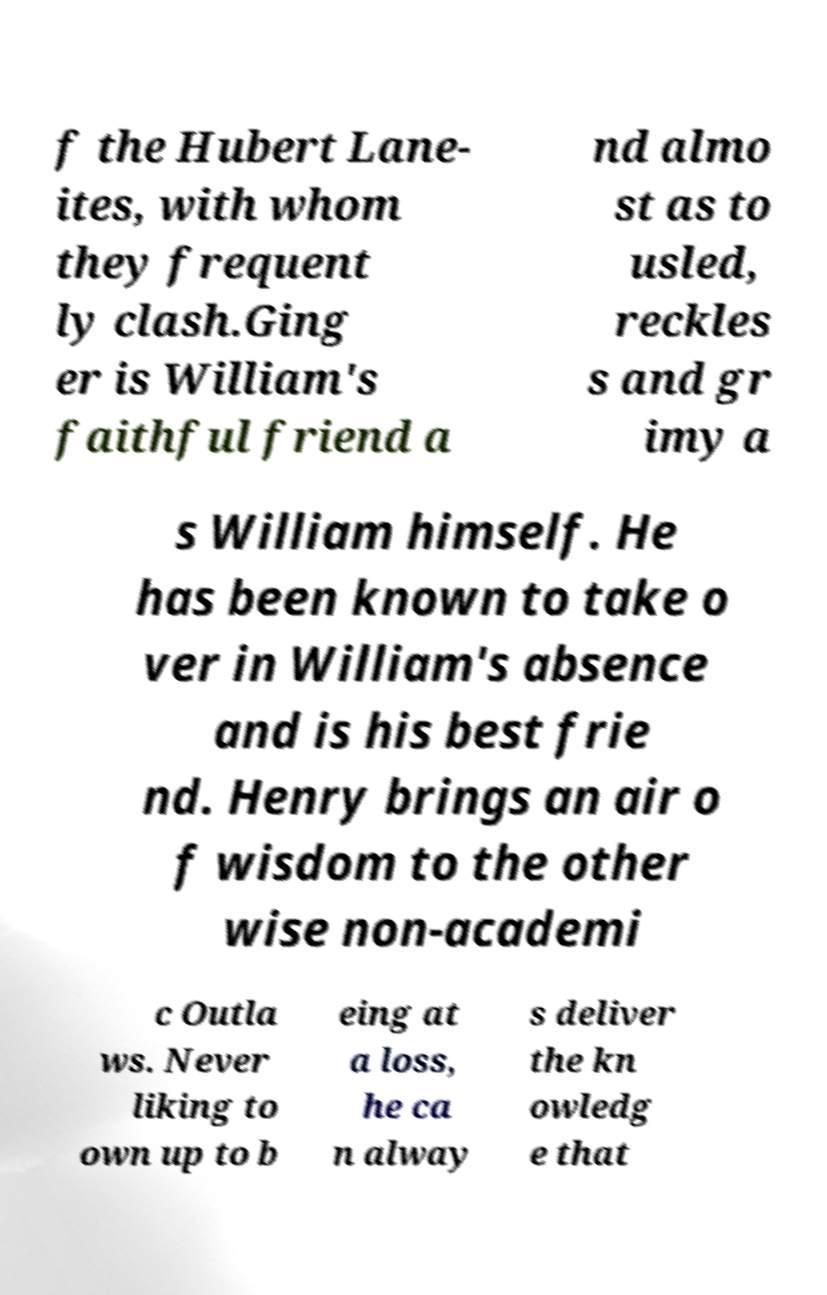For documentation purposes, I need the text within this image transcribed. Could you provide that? f the Hubert Lane- ites, with whom they frequent ly clash.Ging er is William's faithful friend a nd almo st as to usled, reckles s and gr imy a s William himself. He has been known to take o ver in William's absence and is his best frie nd. Henry brings an air o f wisdom to the other wise non-academi c Outla ws. Never liking to own up to b eing at a loss, he ca n alway s deliver the kn owledg e that 